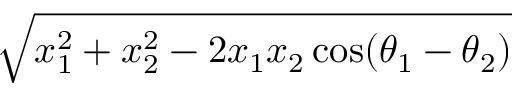<formula> <loc_0><loc_0><loc_500><loc_500>\sqrt { x _ { 1 } ^ { 2 } + x _ { 2 } ^ { 2 } - 2 x _ { 1 } x _ { 2 } \cos ( \theta _ { 1 } - \theta _ { 2 } ) }</formula> 